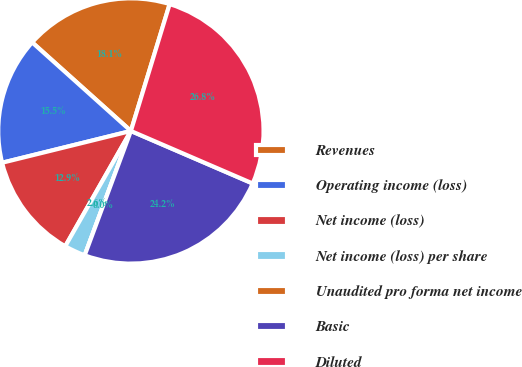Convert chart. <chart><loc_0><loc_0><loc_500><loc_500><pie_chart><fcel>Revenues<fcel>Operating income (loss)<fcel>Net income (loss)<fcel>Net income (loss) per share<fcel>Unaudited pro forma net income<fcel>Basic<fcel>Diluted<nl><fcel>18.08%<fcel>15.49%<fcel>12.91%<fcel>2.58%<fcel>0.0%<fcel>24.18%<fcel>26.76%<nl></chart> 